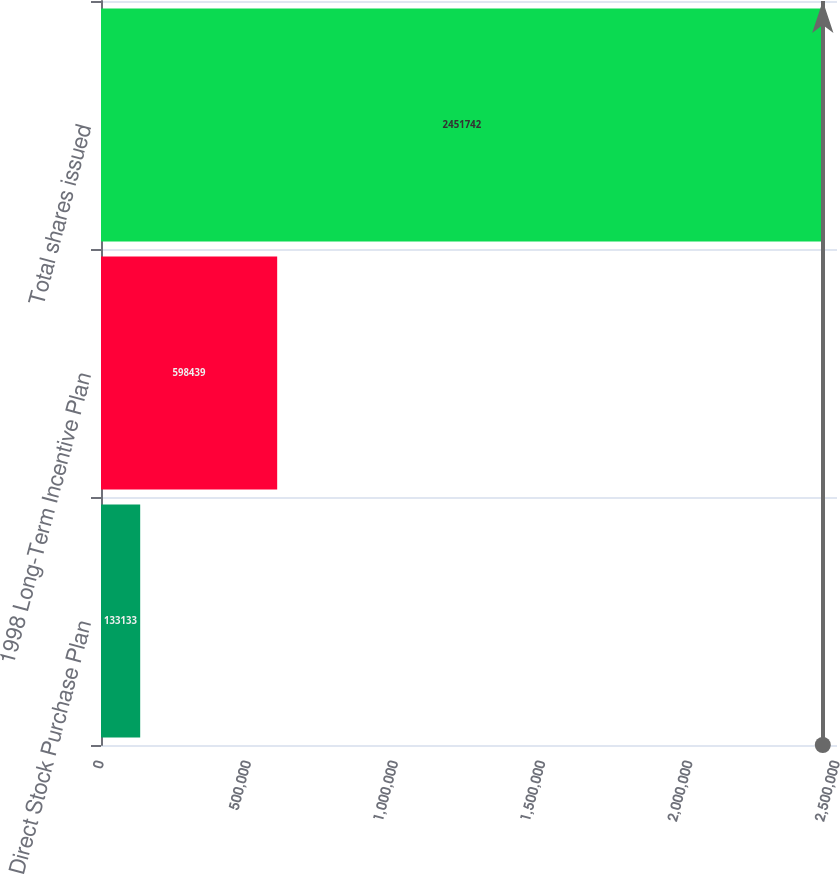<chart> <loc_0><loc_0><loc_500><loc_500><bar_chart><fcel>Direct Stock Purchase Plan<fcel>1998 Long-Term Incentive Plan<fcel>Total shares issued<nl><fcel>133133<fcel>598439<fcel>2.45174e+06<nl></chart> 